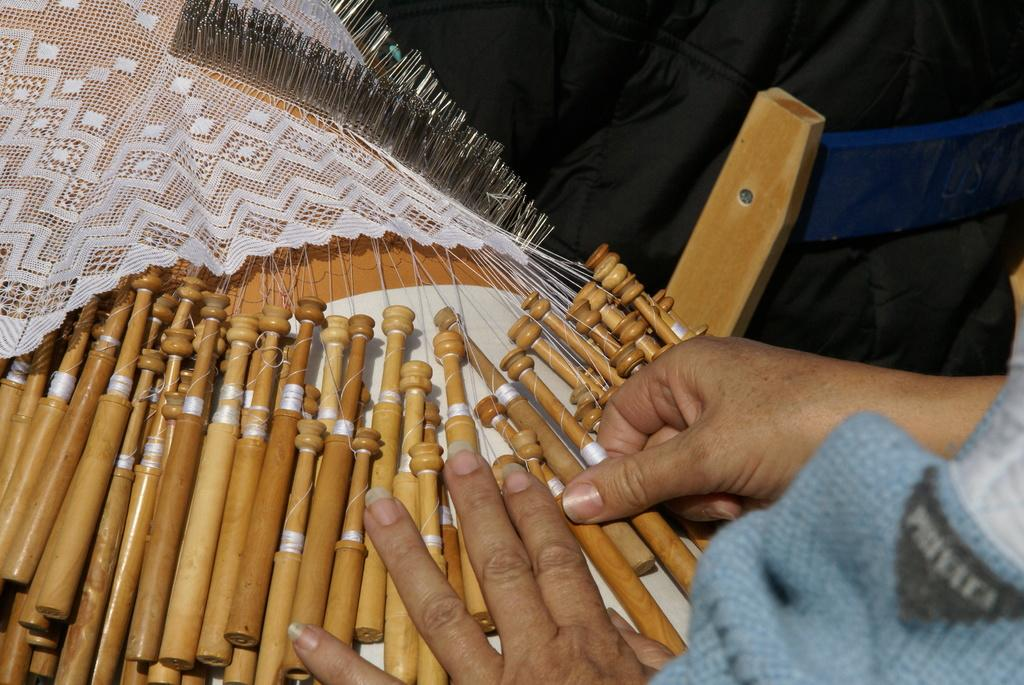What type of material is used for the objects in the image? The objects in the image are made of wood. What is the person in the image doing with a wooden object? The person is holding a wooden object. What colors can be seen in the background of the image? There is a black color object and a white color cloth in the background. What else can be seen in the background of the image? There are other objects visible in the background. What type of egg is being used to create the effect in the image? There is no egg present in the image, and no effect is mentioned or visible. 